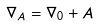<formula> <loc_0><loc_0><loc_500><loc_500>\nabla _ { A } = \nabla _ { 0 } + A</formula> 